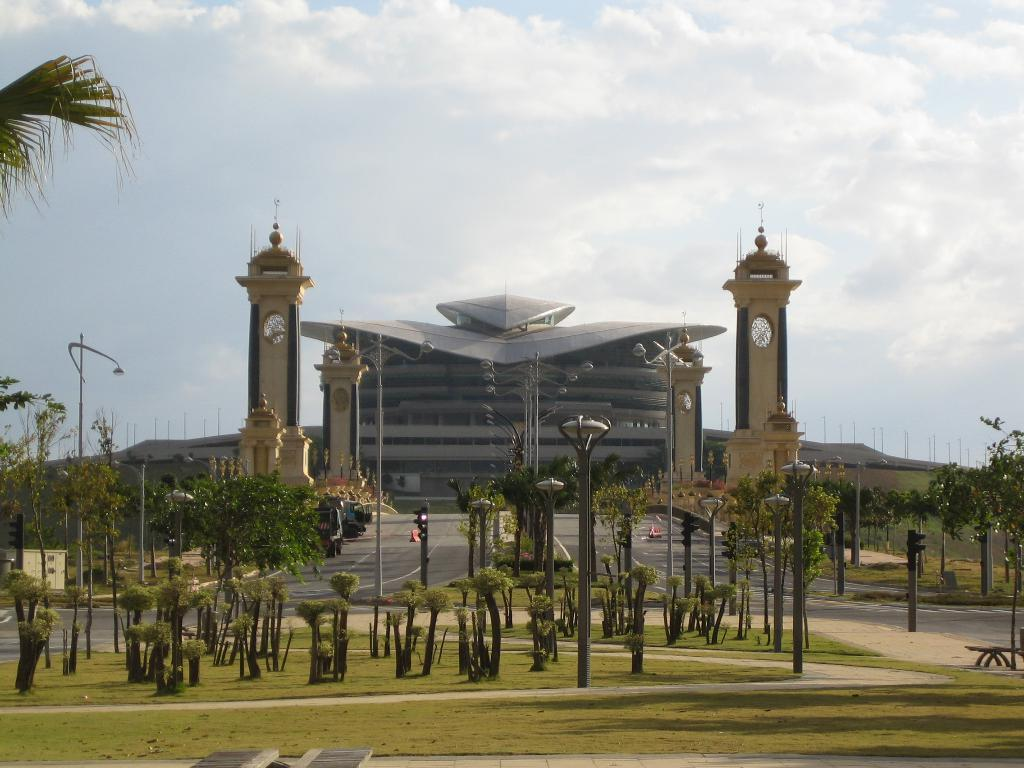What type of area is depicted in the image? There is a garden in the image. What can be found within the garden? There are plants and light poles in the garden. What can be seen in the background of the image? There is a road, pillars, a building, trees, and the sky visible in the background of the image. Where are the books located in the image? There are no books present in the image. Is there a playground visible in the image? There is no playground visible in the image. 